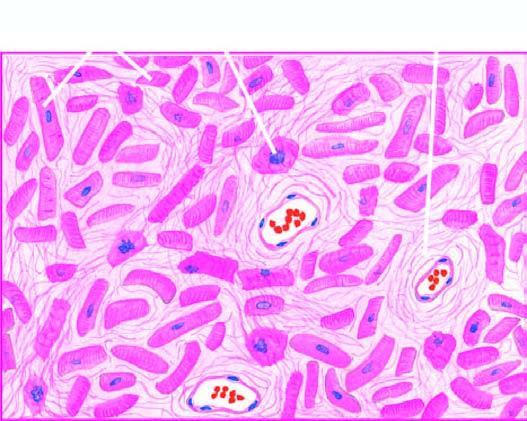what is there?
Answer the question using a single word or phrase. Patchy myocardial fibrosis 